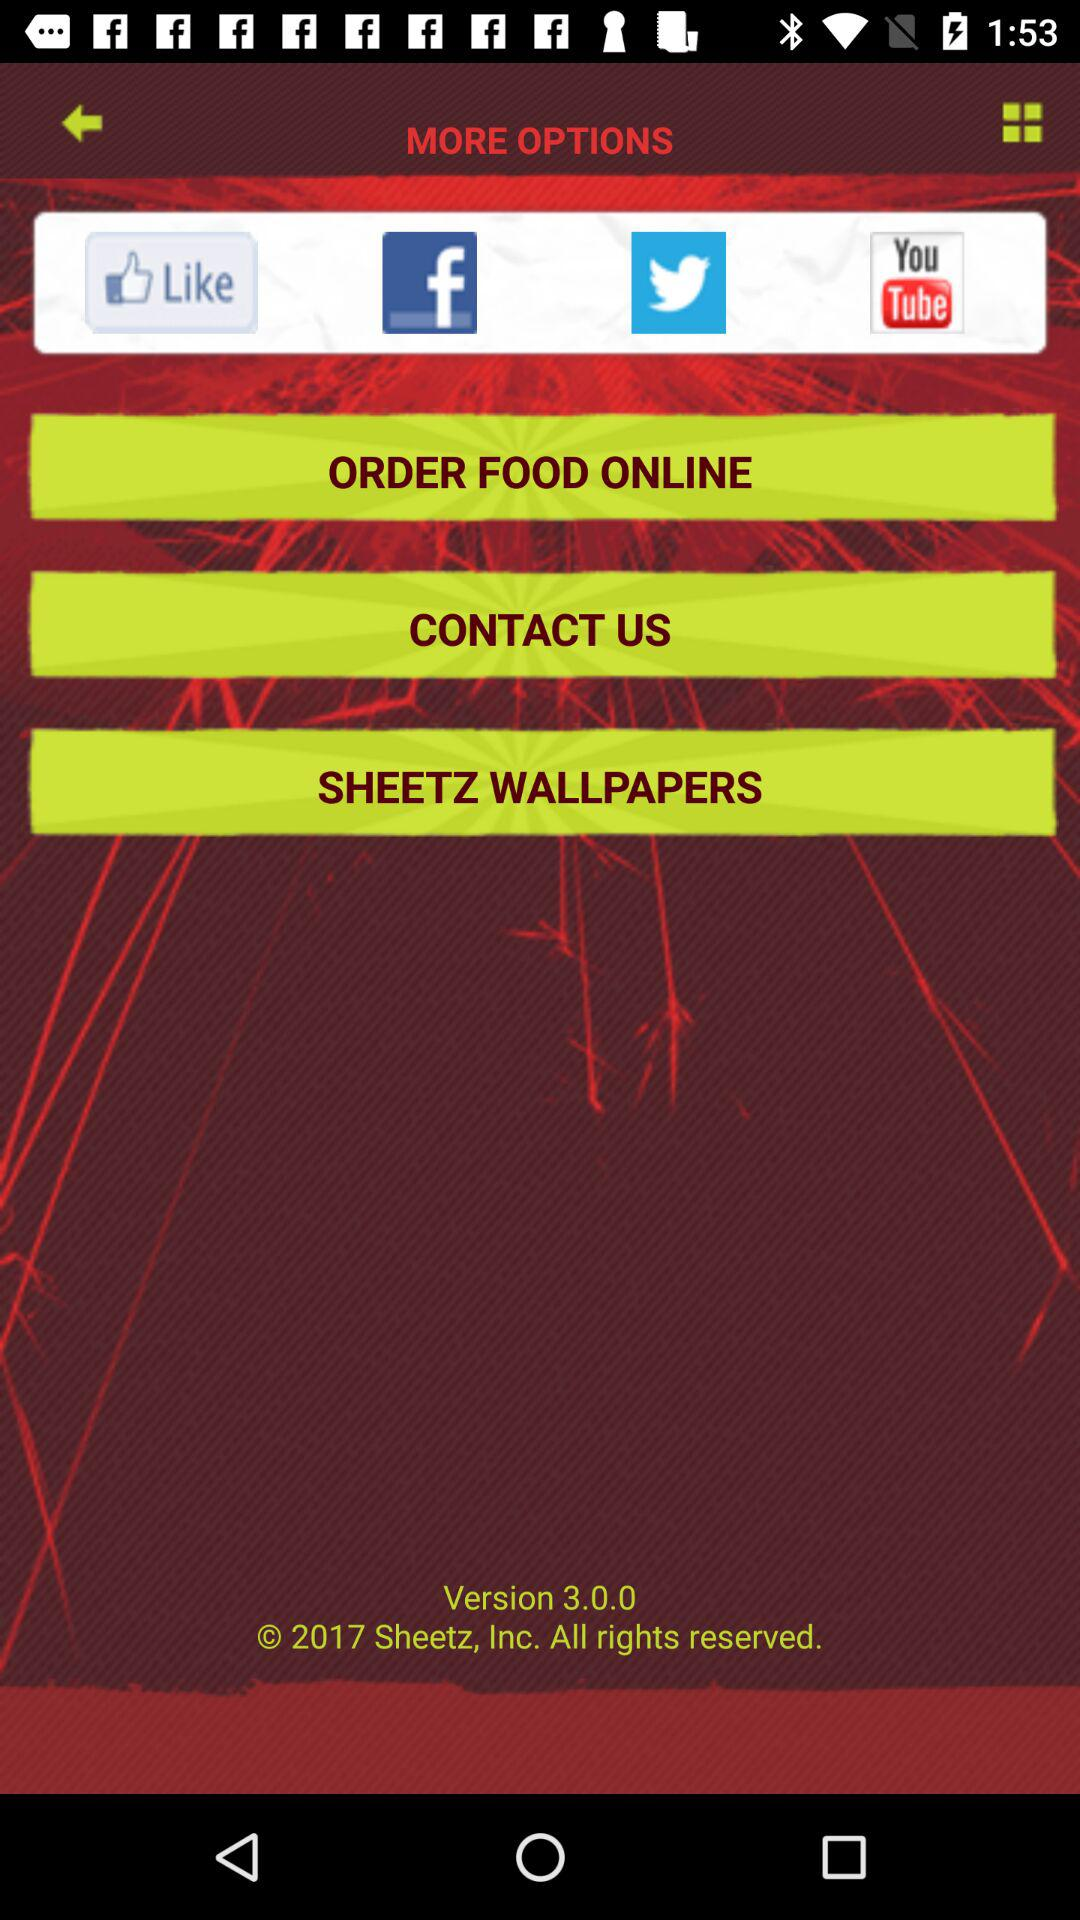What are the social network options available on the screen? The social network options available on the screen are "Facebook", "Twitter" and "YouTube". 